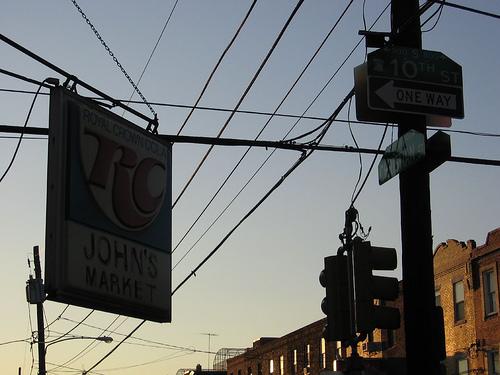Whose market is it?
Be succinct. John's. Is this photo is color?
Concise answer only. Yes. How many power lines are there?
Concise answer only. 6. Is the sign in English?
Concise answer only. Yes. Are there birds on the wires?
Be succinct. No. Which way does the one way traffic turn?
Short answer required. Left. How many power lines are shown?
Write a very short answer. 8. What time of day is it?
Quick response, please. Dusk. 